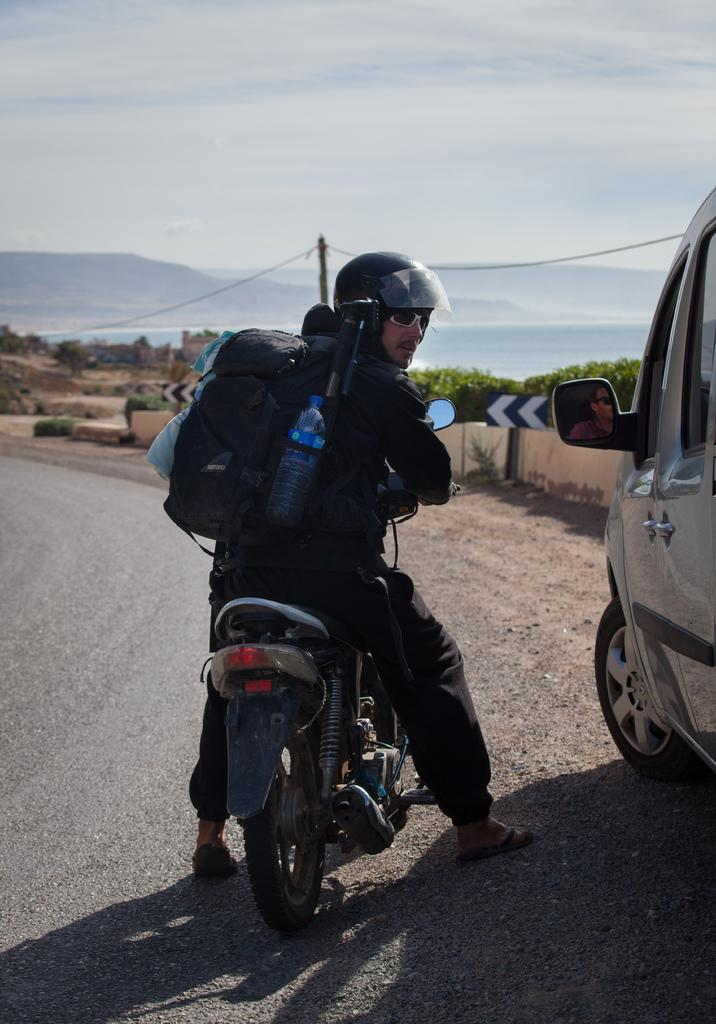What is the main subject of the image? There is a man in the image. What is the man carrying? The man is carrying a backpack. What is the man doing in the image? The man is sitting on a chair. Where is the chair located in relation to the car? The chair is beside a car. What is the car's location in the image? The car is on a road. What can be seen in the background of the image? There are hills in the background of the image. What is visible in the sky in the image? The sky is visible in the image, and there are clouds in the sky. Can you tell me how many rivers are visible in the image? There are no rivers visible in the image. What type of stocking is the man wearing in the image? The image does not show the man's legs or any stockings. 